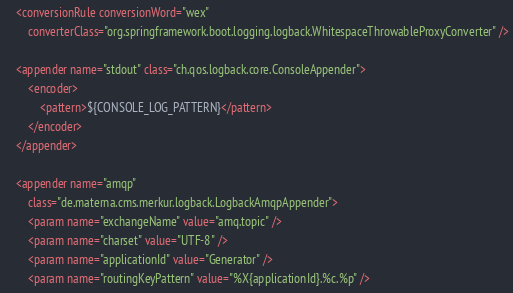<code> <loc_0><loc_0><loc_500><loc_500><_XML_>	<conversionRule conversionWord="wex"
		converterClass="org.springframework.boot.logging.logback.WhitespaceThrowableProxyConverter" />

	<appender name="stdout" class="ch.qos.logback.core.ConsoleAppender">
		<encoder>
			<pattern>${CONSOLE_LOG_PATTERN}</pattern>
		</encoder>
	</appender>

	<appender name="amqp"
		class="de.materna.cms.merkur.logback.LogbackAmqpAppender">
		<param name="exchangeName" value="amq.topic" />
		<param name="charset" value="UTF-8" />
		<param name="applicationId" value="Generator" />
		<param name="routingKeyPattern" value="%X{applicationId}.%c.%p" /></code> 